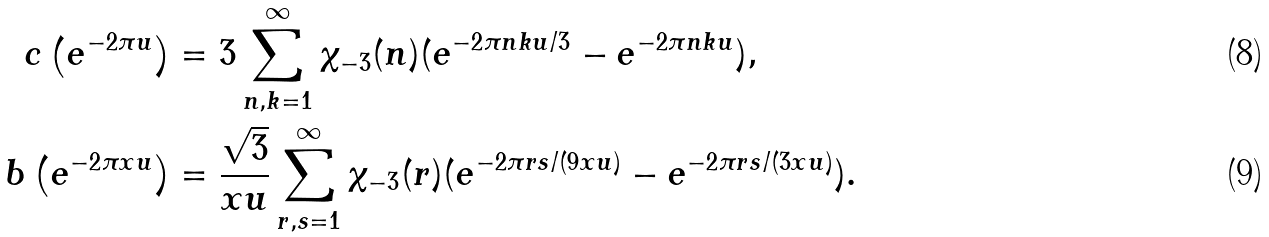Convert formula to latex. <formula><loc_0><loc_0><loc_500><loc_500>c \left ( e ^ { - 2 \pi u } \right ) & = 3 \sum _ { n , k = 1 } ^ { \infty } \chi _ { - 3 } ( n ) ( e ^ { - 2 \pi n k u / 3 } - e ^ { - 2 \pi n k u } ) , \\ b \left ( e ^ { - 2 \pi x u } \right ) & = \frac { \sqrt { 3 } } { x u } \sum _ { r , s = 1 } ^ { \infty } \chi _ { - 3 } ( r ) ( e ^ { - 2 \pi r s / ( 9 x u ) } - e ^ { - 2 \pi r s / ( 3 x u ) } ) .</formula> 